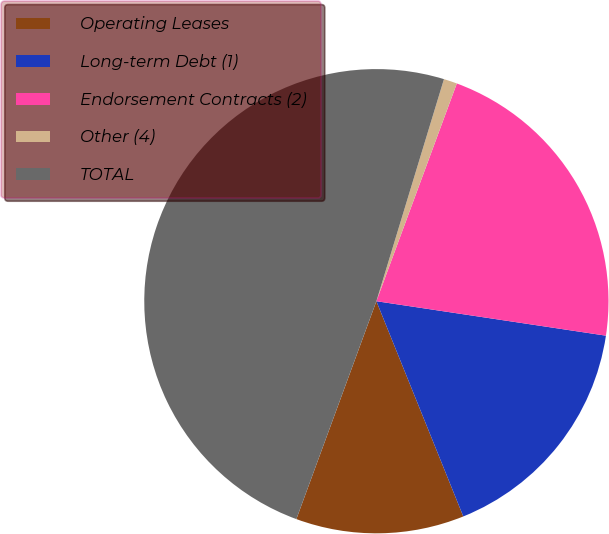<chart> <loc_0><loc_0><loc_500><loc_500><pie_chart><fcel>Operating Leases<fcel>Long-term Debt (1)<fcel>Endorsement Contracts (2)<fcel>Other (4)<fcel>TOTAL<nl><fcel>11.71%<fcel>16.52%<fcel>21.74%<fcel>0.93%<fcel>49.1%<nl></chart> 